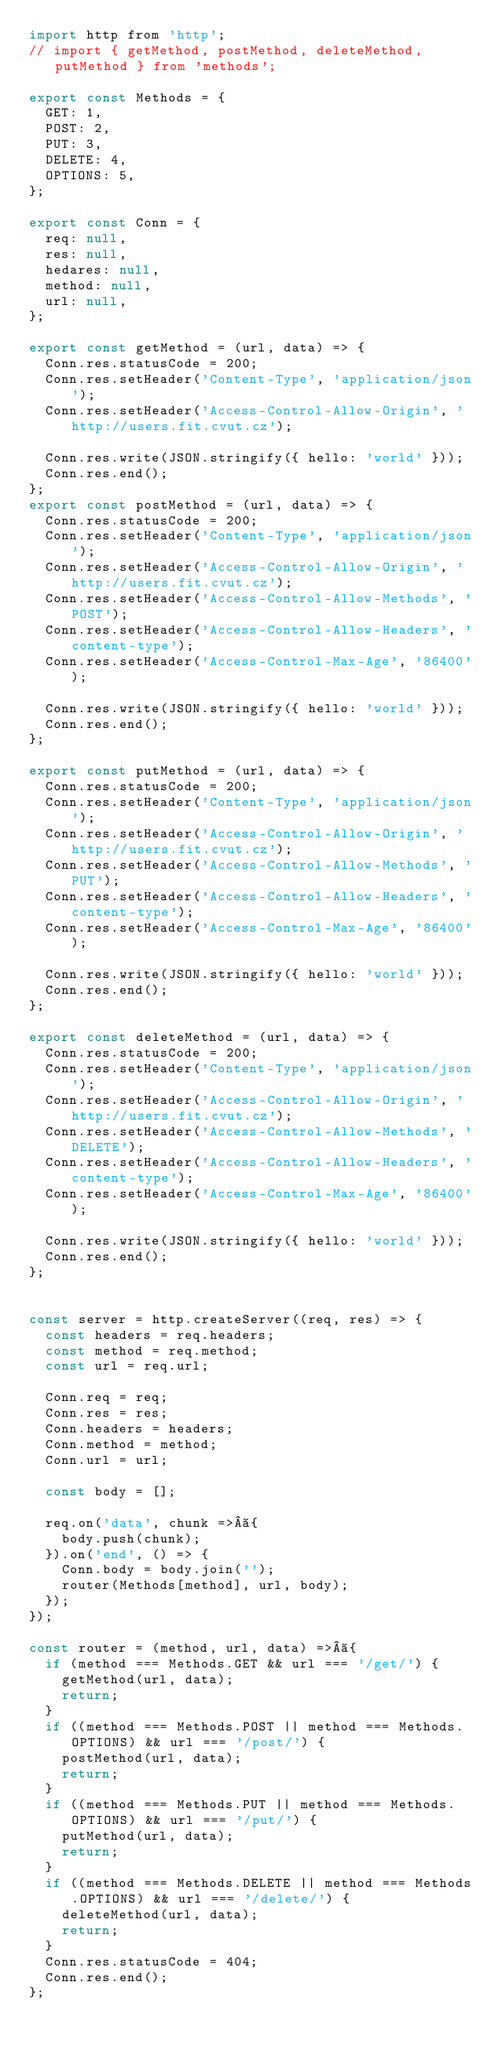Convert code to text. <code><loc_0><loc_0><loc_500><loc_500><_JavaScript_>import http from 'http';
// import { getMethod, postMethod, deleteMethod, putMethod } from 'methods';

export const Methods = {
  GET: 1,
  POST: 2,
  PUT: 3,
  DELETE: 4,
  OPTIONS: 5,
};

export const Conn = {
  req: null,
  res: null,
  hedares: null,
  method: null,
  url: null,
};

export const getMethod = (url, data) => {
  Conn.res.statusCode = 200;
  Conn.res.setHeader('Content-Type', 'application/json');
  Conn.res.setHeader('Access-Control-Allow-Origin', 'http://users.fit.cvut.cz');

  Conn.res.write(JSON.stringify({ hello: 'world' }));
  Conn.res.end();
};
export const postMethod = (url, data) => {
  Conn.res.statusCode = 200;
  Conn.res.setHeader('Content-Type', 'application/json');
  Conn.res.setHeader('Access-Control-Allow-Origin', 'http://users.fit.cvut.cz');
  Conn.res.setHeader('Access-Control-Allow-Methods', 'POST');
  Conn.res.setHeader('Access-Control-Allow-Headers', 'content-type');
  Conn.res.setHeader('Access-Control-Max-Age', '86400');

  Conn.res.write(JSON.stringify({ hello: 'world' }));
  Conn.res.end();
};

export const putMethod = (url, data) => {
  Conn.res.statusCode = 200;
  Conn.res.setHeader('Content-Type', 'application/json');
  Conn.res.setHeader('Access-Control-Allow-Origin', 'http://users.fit.cvut.cz');
  Conn.res.setHeader('Access-Control-Allow-Methods', 'PUT');
  Conn.res.setHeader('Access-Control-Allow-Headers', 'content-type');
  Conn.res.setHeader('Access-Control-Max-Age', '86400');

  Conn.res.write(JSON.stringify({ hello: 'world' }));
  Conn.res.end();
};

export const deleteMethod = (url, data) => {
  Conn.res.statusCode = 200;
  Conn.res.setHeader('Content-Type', 'application/json');
  Conn.res.setHeader('Access-Control-Allow-Origin', 'http://users.fit.cvut.cz');
  Conn.res.setHeader('Access-Control-Allow-Methods', 'DELETE');
  Conn.res.setHeader('Access-Control-Allow-Headers', 'content-type');
  Conn.res.setHeader('Access-Control-Max-Age', '86400');

  Conn.res.write(JSON.stringify({ hello: 'world' }));
  Conn.res.end();
};


const server = http.createServer((req, res) => {
  const headers = req.headers;
  const method = req.method;
  const url = req.url;

  Conn.req = req;
  Conn.res = res;
  Conn.headers = headers;
  Conn.method = method;
  Conn.url = url;

  const body = [];

  req.on('data', chunk => {
    body.push(chunk);
  }).on('end', () => {
    Conn.body = body.join('');
    router(Methods[method], url, body);
  });
});

const router = (method, url, data) => {
  if (method === Methods.GET && url === '/get/') {
    getMethod(url, data);
    return;
  }
  if ((method === Methods.POST || method === Methods.OPTIONS) && url === '/post/') {
    postMethod(url, data);
    return;
  }
  if ((method === Methods.PUT || method === Methods.OPTIONS) && url === '/put/') {
    putMethod(url, data);
    return;
  }
  if ((method === Methods.DELETE || method === Methods.OPTIONS) && url === '/delete/') {
    deleteMethod(url, data);
    return;
  }
  Conn.res.statusCode = 404;
  Conn.res.end();
};
</code> 